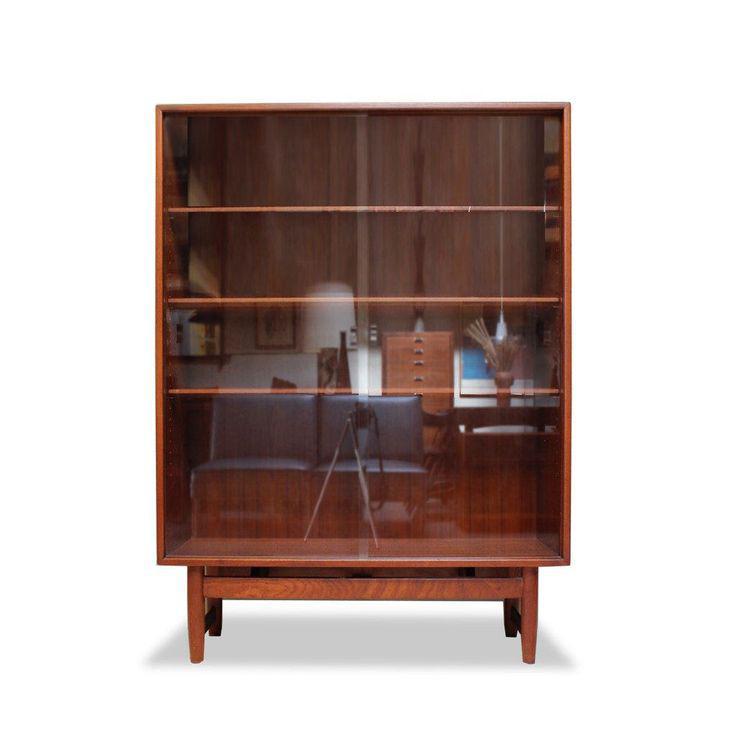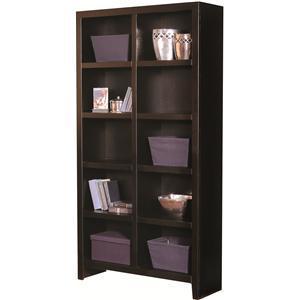The first image is the image on the left, the second image is the image on the right. Considering the images on both sides, is "In one image, a bookcase has a drawer in addition to open shelving." valid? Answer yes or no. No. 